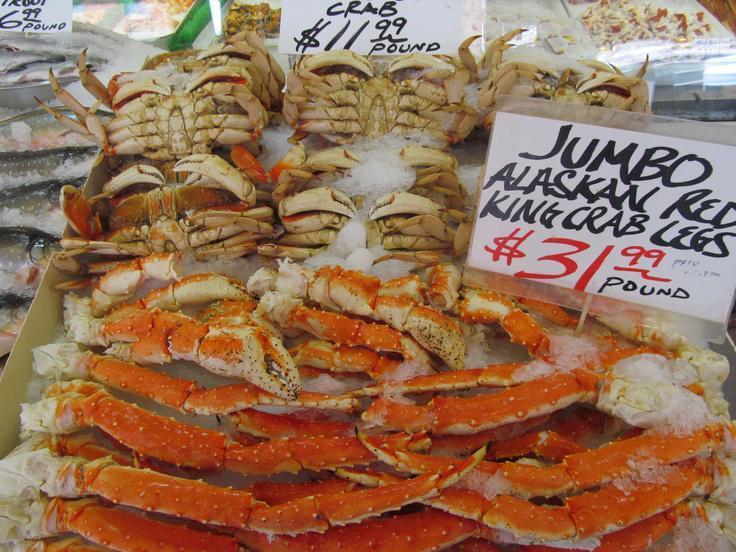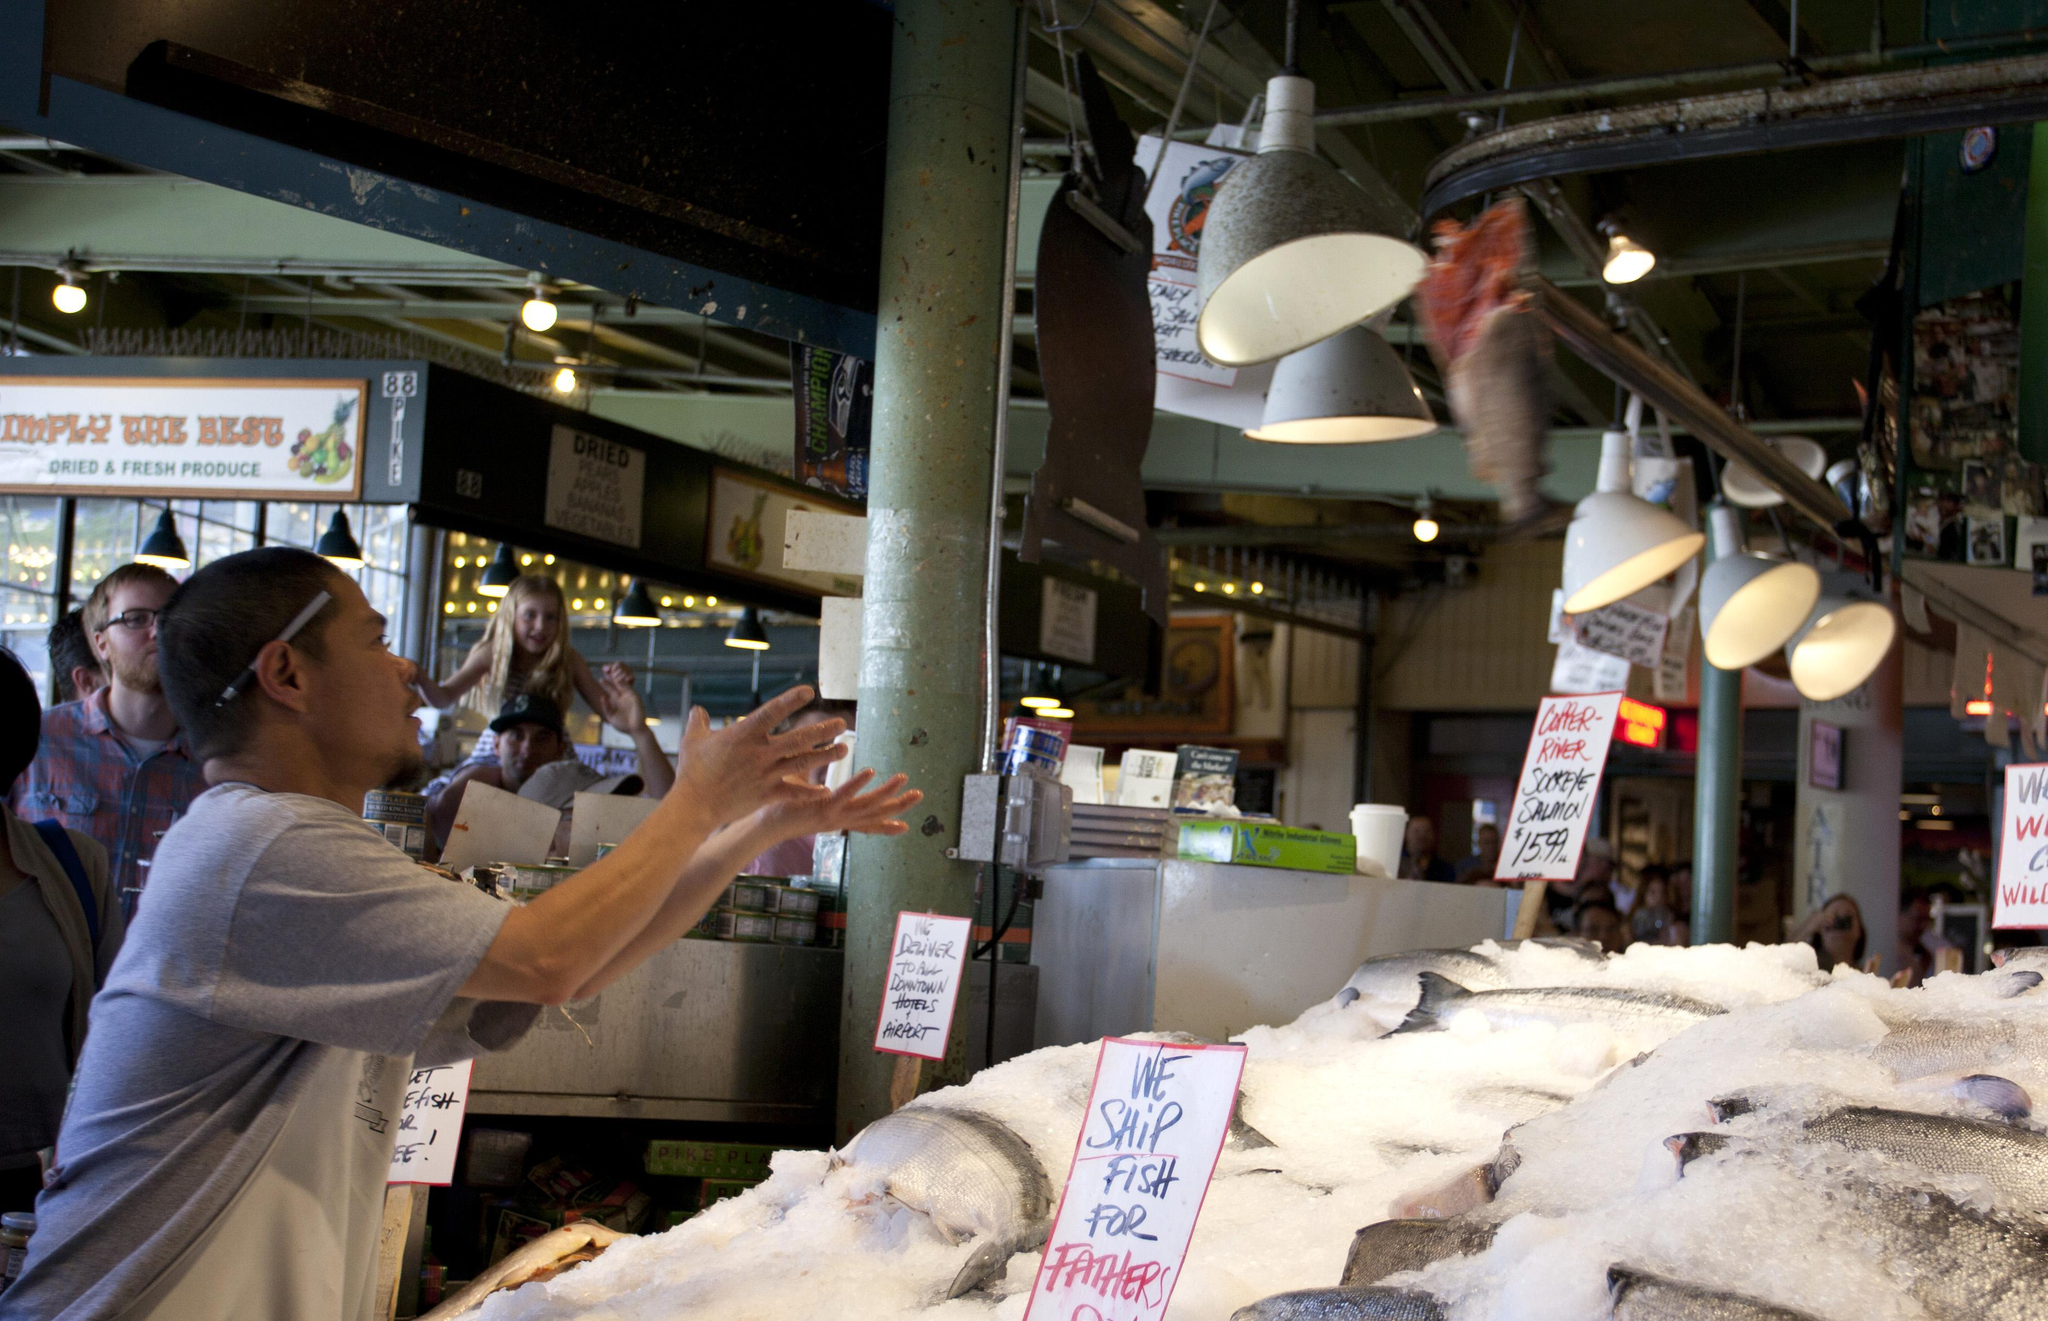The first image is the image on the left, the second image is the image on the right. For the images shown, is this caption "An image shows a man standing in front of a display of fish with his arms raised to catch a fish coming toward him." true? Answer yes or no. Yes. The first image is the image on the left, the second image is the image on the right. Assess this claim about the two images: "In one image, a man near a display of iced fish has his arms outstretched, while a second image shows iced crabs and crab legs for sale.". Correct or not? Answer yes or no. Yes. 